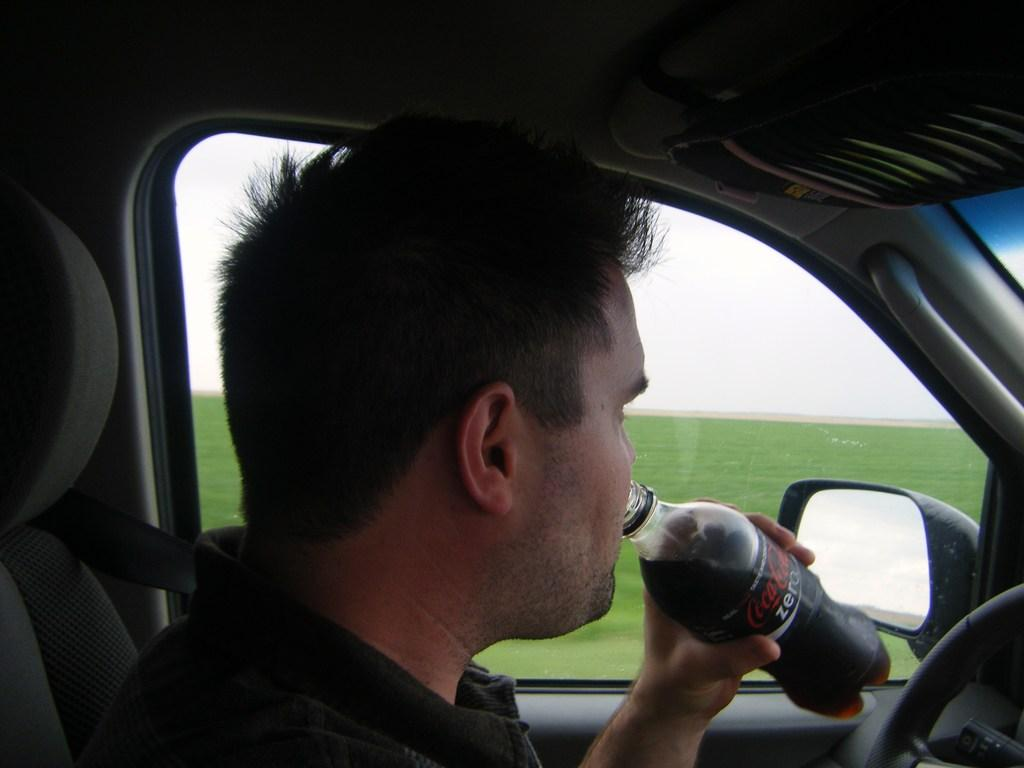What is the person in the image doing? The person is drinking Coca-Cola. What is the person holding in the image? The person is holding a bottle. Where is the person located in the image? The person is inside a car. What is the person holding while inside the car? The person is holding a steering wheel. What can be seen in the background of the image? There is green-colored grass in the background. What is the condition of the sky in the image? The sky is cloudy. What type of spot can be seen on the person's lip in the image? There is no spot visible on the person's lip in the image. Is there a robin perched on the person's shoulder in the image? There is no robin present in the image. 